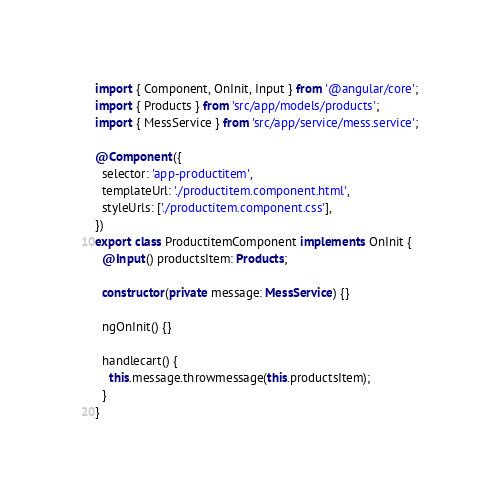<code> <loc_0><loc_0><loc_500><loc_500><_TypeScript_>import { Component, OnInit, Input } from '@angular/core';
import { Products } from 'src/app/models/products';
import { MessService } from 'src/app/service/mess.service';

@Component({
  selector: 'app-productitem',
  templateUrl: './productitem.component.html',
  styleUrls: ['./productitem.component.css'],
})
export class ProductitemComponent implements OnInit {
  @Input() productsItem: Products;

  constructor(private message: MessService) {}

  ngOnInit() {}

  handlecart() {
    this.message.throwmessage(this.productsItem);
  }
}
</code> 